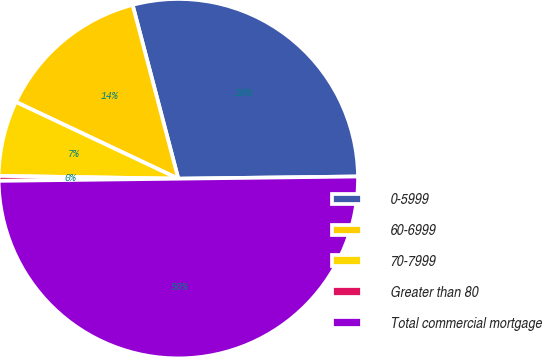Convert chart. <chart><loc_0><loc_0><loc_500><loc_500><pie_chart><fcel>0-5999<fcel>60-6999<fcel>70-7999<fcel>Greater than 80<fcel>Total commercial mortgage<nl><fcel>28.9%<fcel>13.88%<fcel>6.78%<fcel>0.44%<fcel>50.0%<nl></chart> 